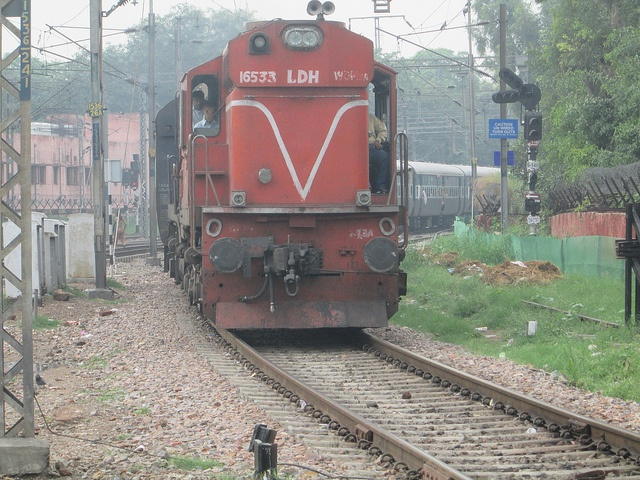Describe the objects in this image and their specific colors. I can see train in darkgray, gray, brown, and lightgray tones, people in darkgray, gray, darkblue, and black tones, traffic light in darkgray and gray tones, people in darkgray and gray tones, and people in darkgray and gray tones in this image. 